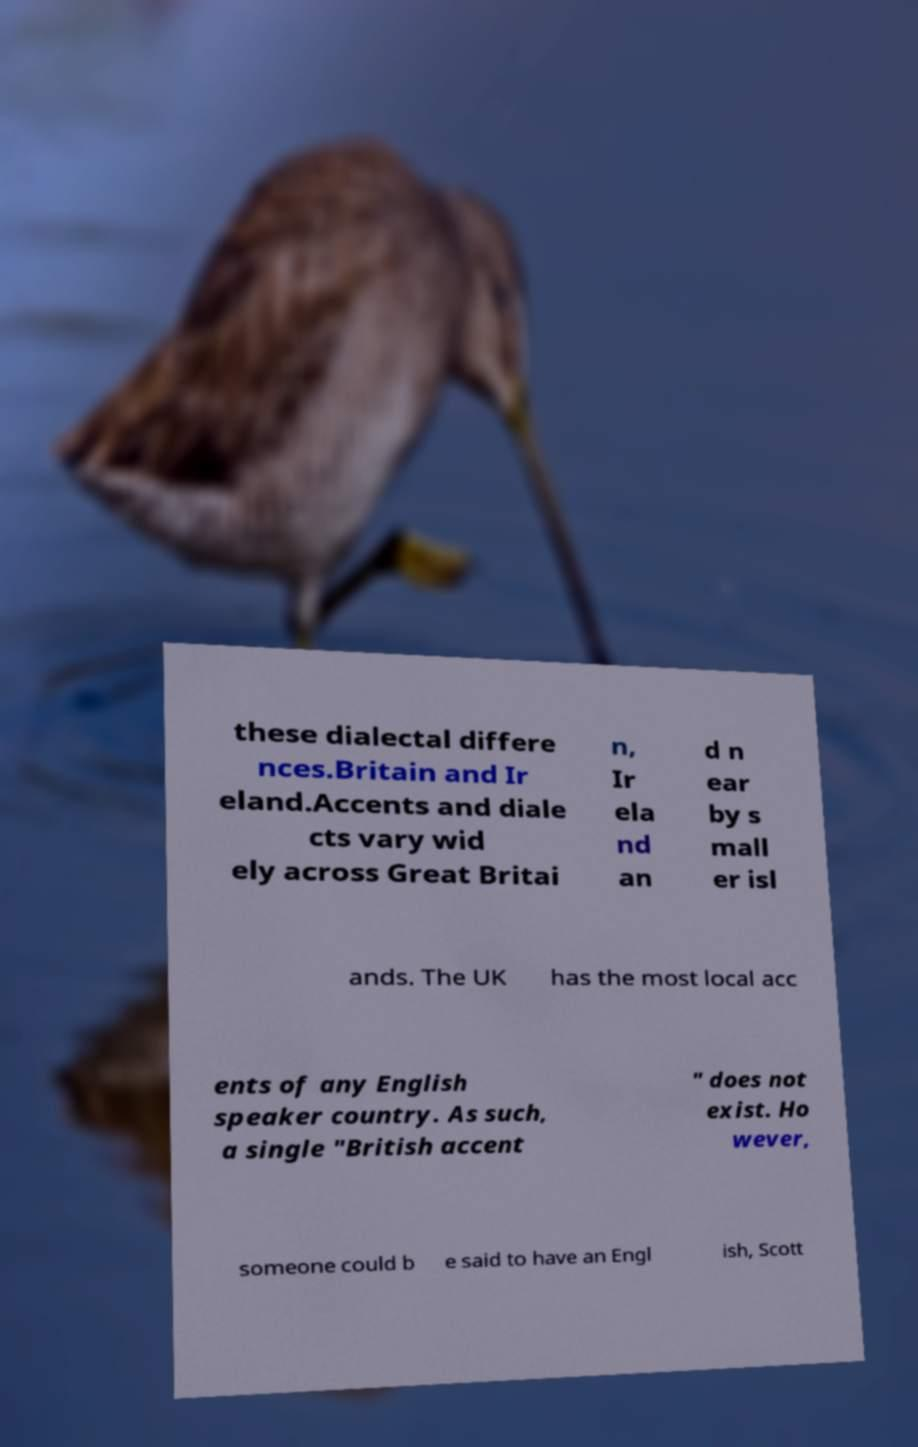Could you assist in decoding the text presented in this image and type it out clearly? these dialectal differe nces.Britain and Ir eland.Accents and diale cts vary wid ely across Great Britai n, Ir ela nd an d n ear by s mall er isl ands. The UK has the most local acc ents of any English speaker country. As such, a single "British accent " does not exist. Ho wever, someone could b e said to have an Engl ish, Scott 